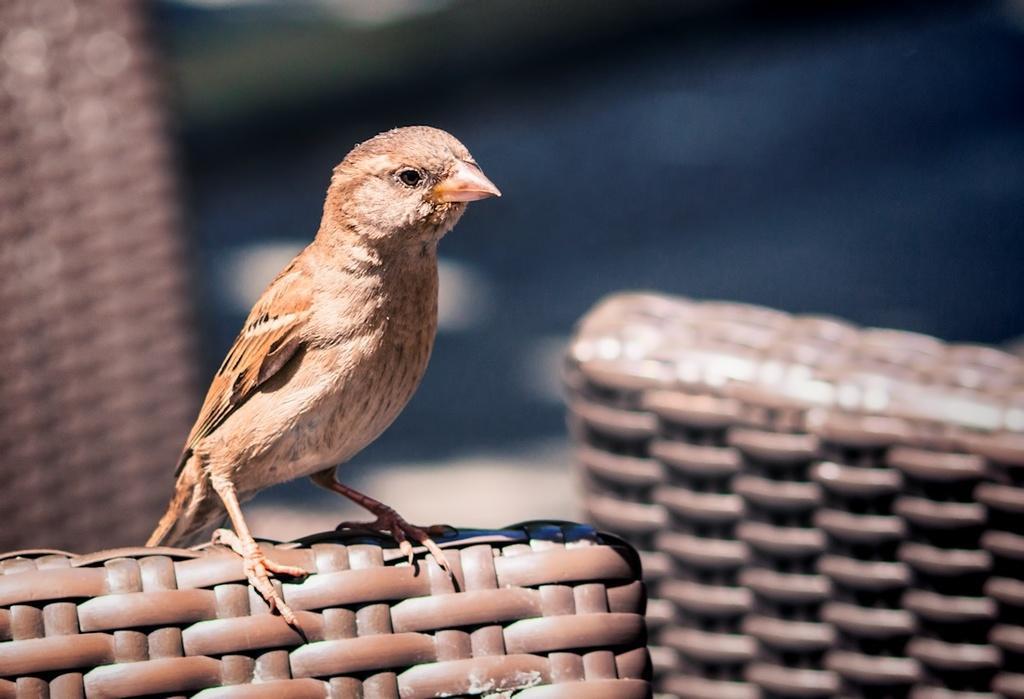Describe this image in one or two sentences. In this image, we can see a bird sitting on an object and there is a blurred background. 